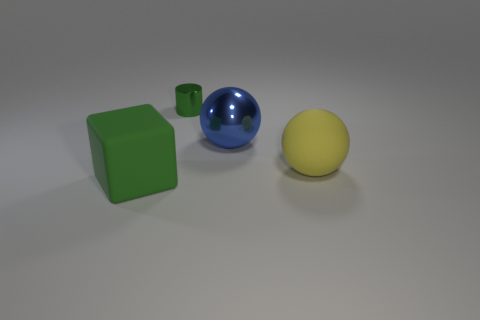Is there any other thing that has the same size as the green shiny object?
Give a very brief answer. No. Is the rubber block the same color as the small metal thing?
Provide a short and direct response. Yes. What is the color of the big block?
Provide a short and direct response. Green. What number of things are the same color as the big cube?
Offer a terse response. 1. There is a green block; are there any big matte objects behind it?
Give a very brief answer. Yes. Are there the same number of small shiny objects that are to the right of the large metal object and rubber things to the left of the small metallic object?
Give a very brief answer. No. There is a matte object left of the green metallic object; does it have the same size as the sphere behind the big yellow object?
Your response must be concise. Yes. There is a big rubber object that is right of the large sphere that is behind the yellow matte ball that is right of the small green thing; what shape is it?
Offer a terse response. Sphere. What size is the other rubber thing that is the same shape as the blue object?
Your response must be concise. Large. What color is the object that is behind the big green cube and to the left of the big blue object?
Give a very brief answer. Green. 